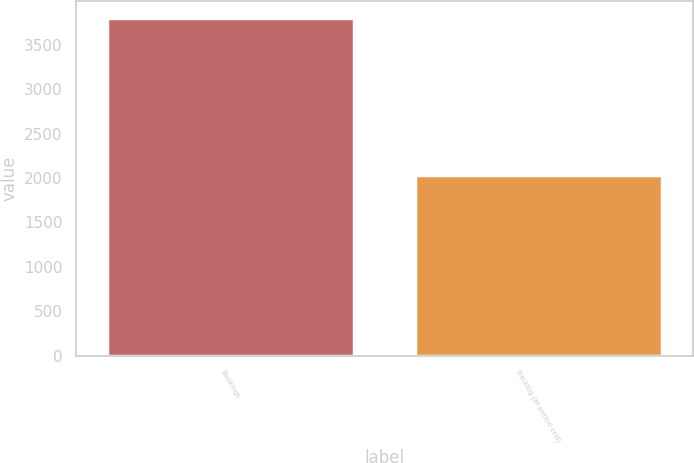Convert chart. <chart><loc_0><loc_0><loc_500><loc_500><bar_chart><fcel>Bookings<fcel>Backlog (at period end)<nl><fcel>3803.9<fcel>2033.4<nl></chart> 